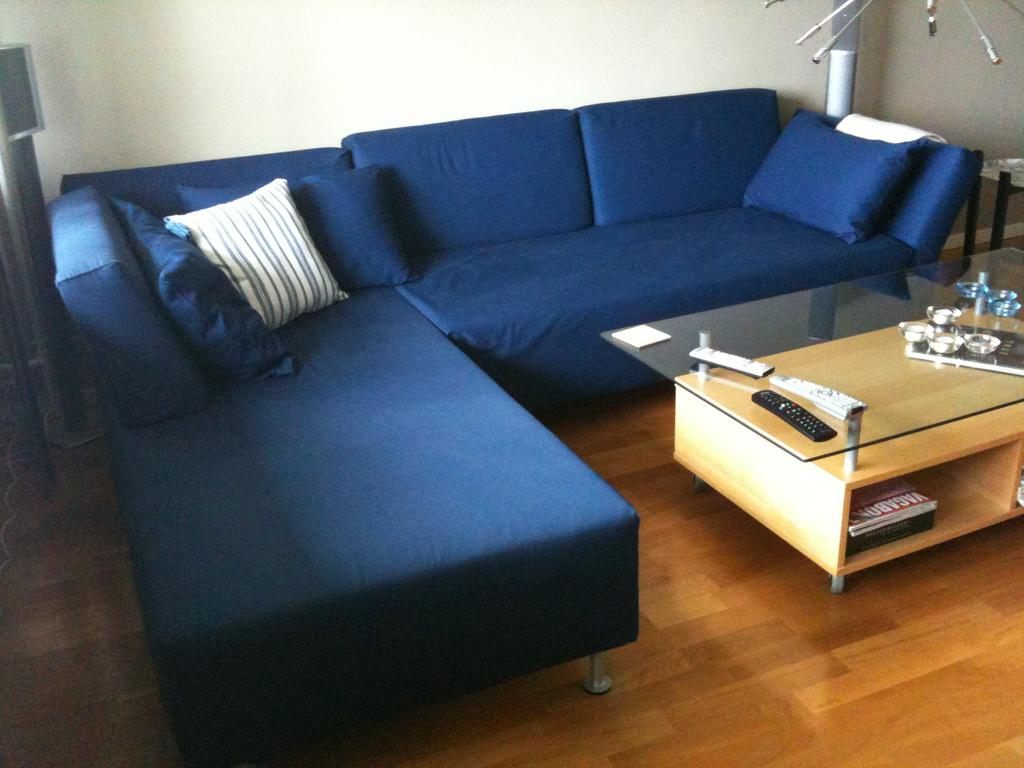What type of furniture is in the room? There is a sofa in the room. What is placed on the sofa? There are pillows on the sofa. What other piece of furniture is in the room? There is a table in the room. What items can be found on the table? There are bowls and remotes on the table. What time of day is it in the image? The provided facts do not mention the time of day, so it cannot be determined from the image. 